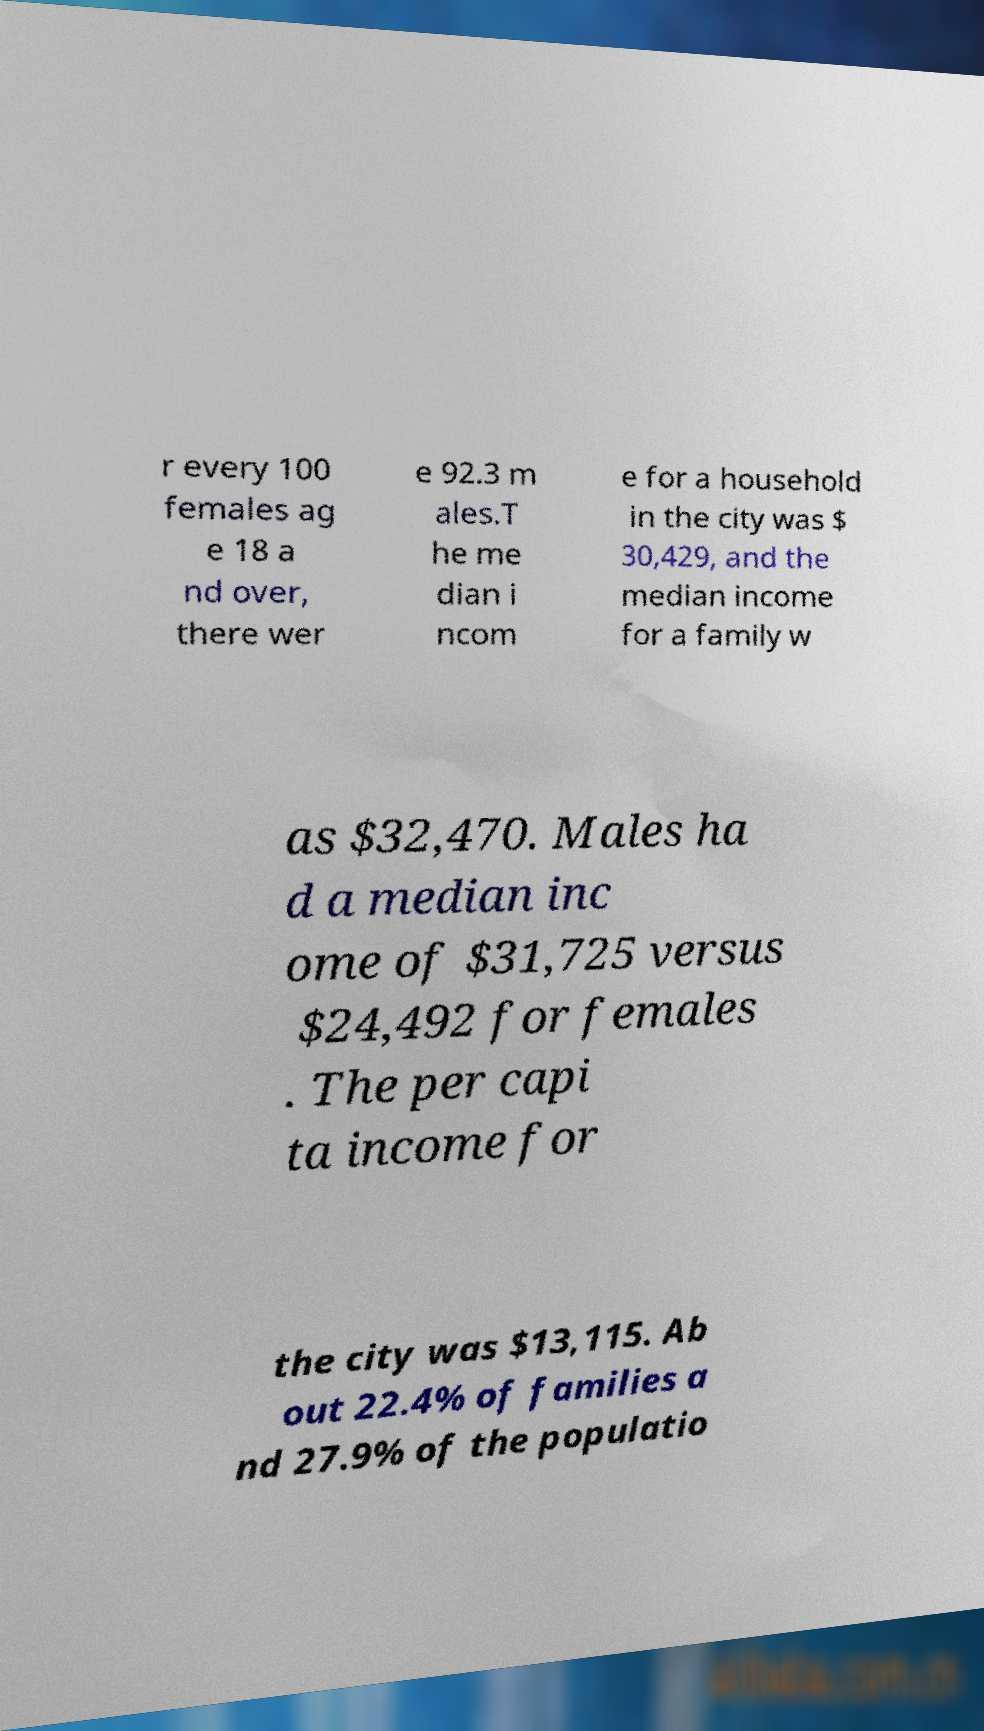What messages or text are displayed in this image? I need them in a readable, typed format. r every 100 females ag e 18 a nd over, there wer e 92.3 m ales.T he me dian i ncom e for a household in the city was $ 30,429, and the median income for a family w as $32,470. Males ha d a median inc ome of $31,725 versus $24,492 for females . The per capi ta income for the city was $13,115. Ab out 22.4% of families a nd 27.9% of the populatio 